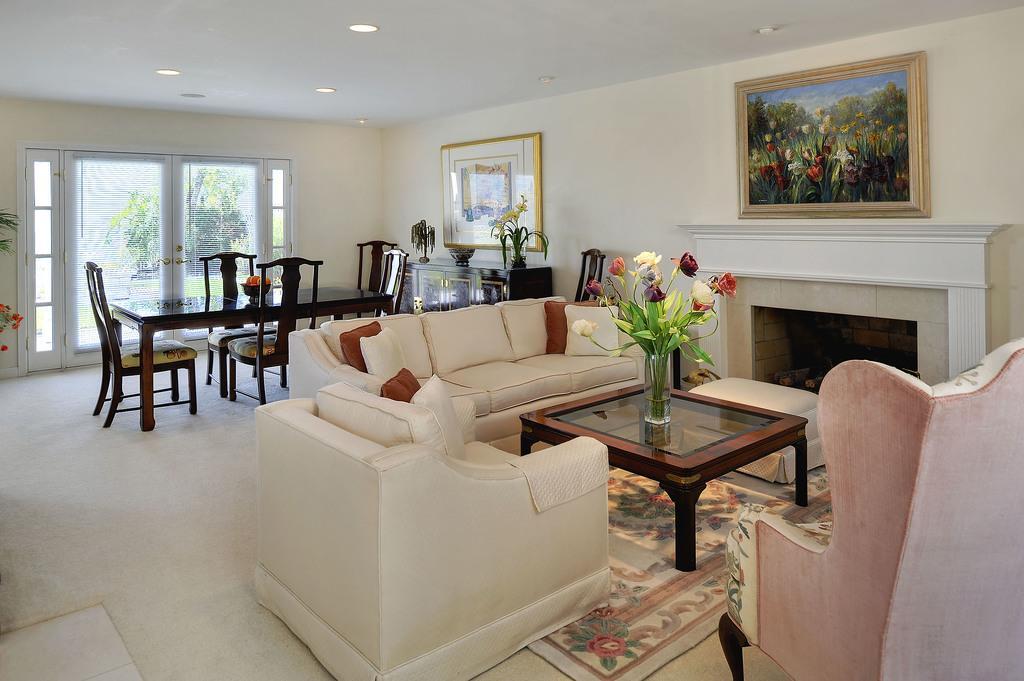How would you summarize this image in a sentence or two? This looks like a living room. This is the white couch with cushions on it. This is the teapoy with the flower vase. This is the dining table with fruits bowl and chairs. These are the photo frames attached to the wall. This looks like a fireplace. These are the glass doors with door handle. 